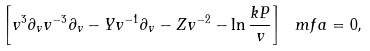<formula> <loc_0><loc_0><loc_500><loc_500>\left [ v ^ { 3 } \partial _ { v } v ^ { - 3 } \partial _ { v } - Y v ^ { - 1 } \partial _ { v } - Z v ^ { - 2 } - \ln \frac { k P } { v } \right ] \ m f a = 0 ,</formula> 